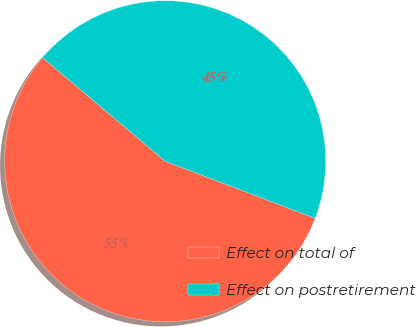<chart> <loc_0><loc_0><loc_500><loc_500><pie_chart><fcel>Effect on total of<fcel>Effect on postretirement<nl><fcel>55.37%<fcel>44.63%<nl></chart> 